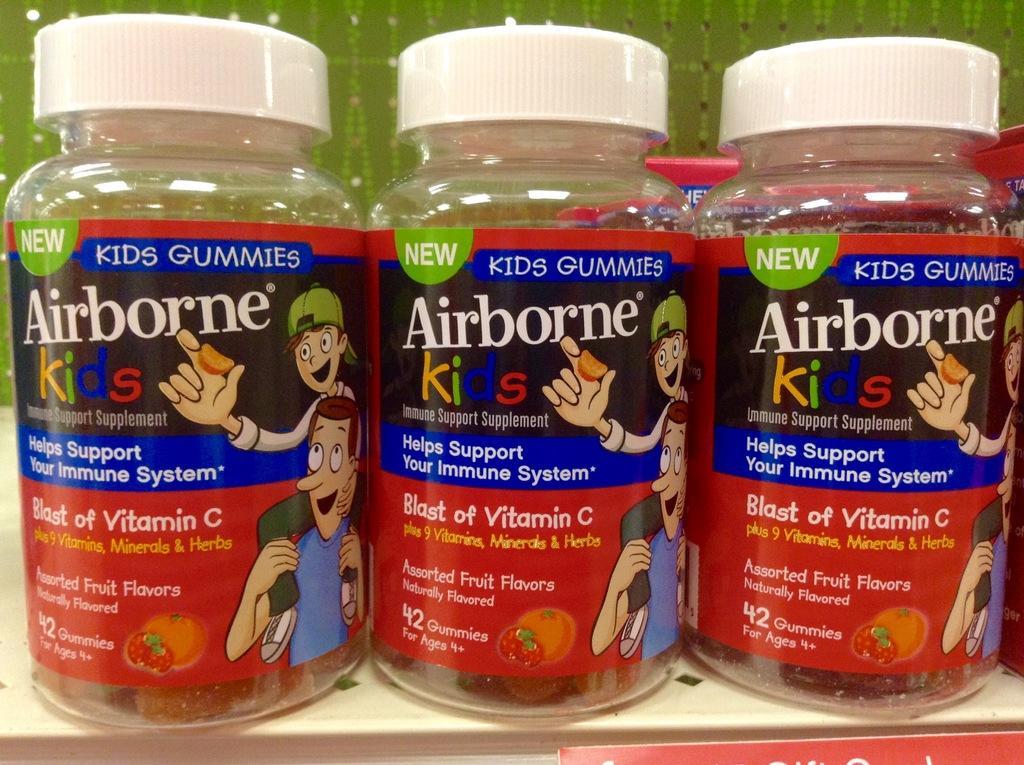How would you summarize this image in a sentence or two? In this image, we can see three bottles, on that bottles AIRBORNE KIDS is printed on the stickers, there are three white color caps on the bottles. 